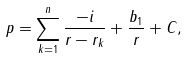Convert formula to latex. <formula><loc_0><loc_0><loc_500><loc_500>p = \sum _ { k = 1 } ^ { n } \frac { - i } { r - r _ { k } } + \frac { b _ { 1 } } { r } + C ,</formula> 